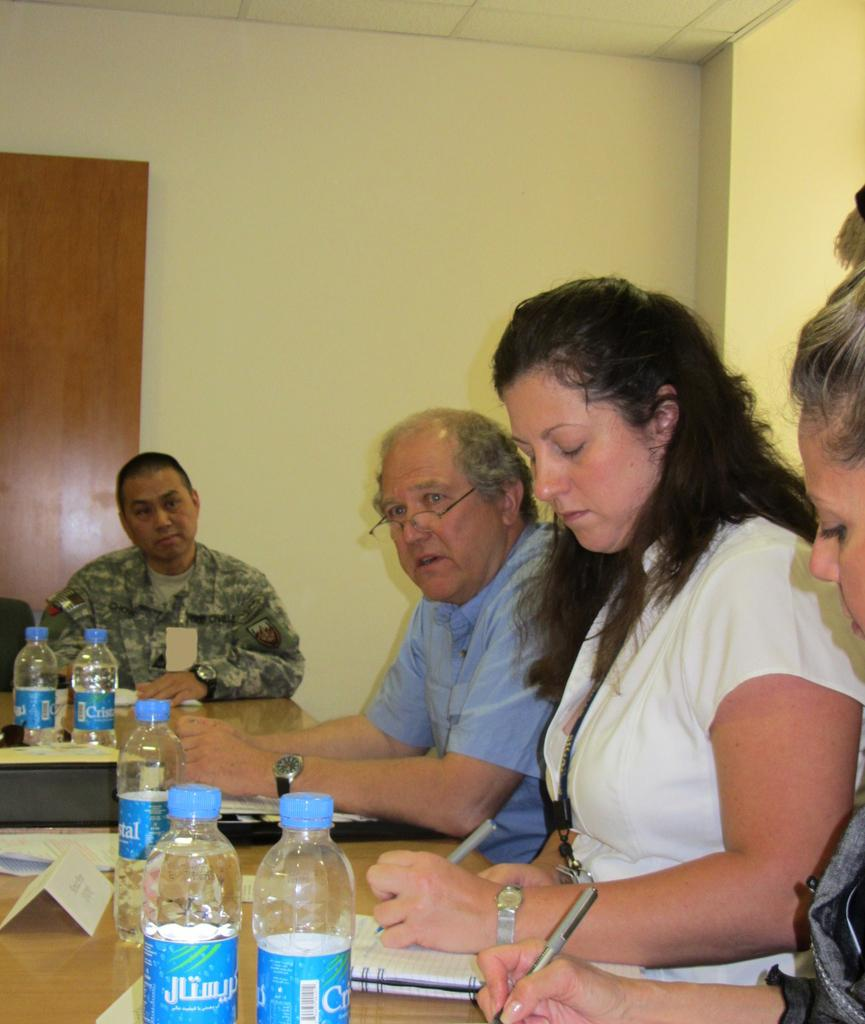How many people are in the image? There is a group of persons in the image. What are the persons doing in the image? The persons are sitting on chairs and writing something. What can be seen on top of the table in the image? There are bottles on top of a table. What type of punishment is being administered to the servant in the image? There is no servant or punishment present in the image. 